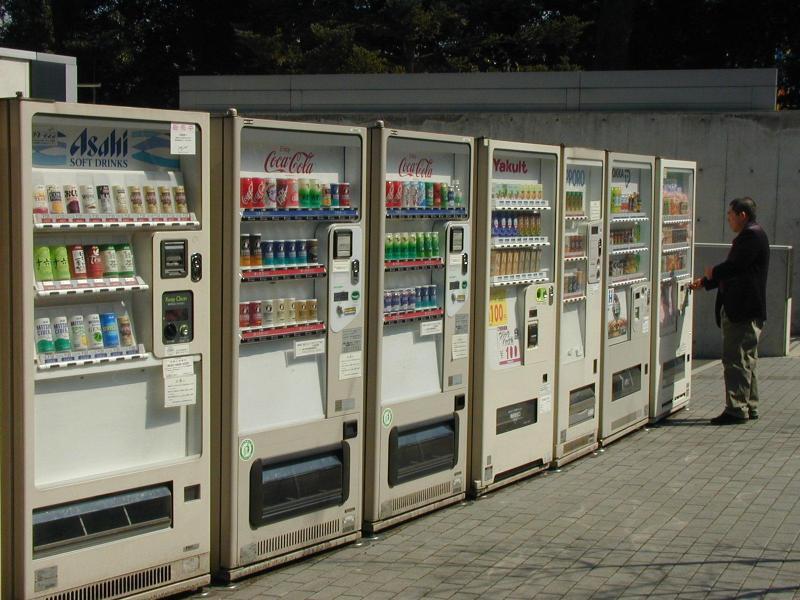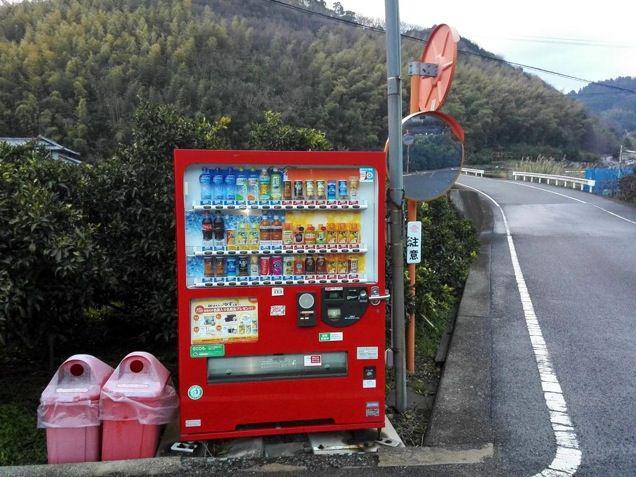The first image is the image on the left, the second image is the image on the right. Evaluate the accuracy of this statement regarding the images: "In one image, trash containers are sitting beside a vending machine.". Is it true? Answer yes or no. Yes. The first image is the image on the left, the second image is the image on the right. Given the left and right images, does the statement "One image contains exactly one red vending machine." hold true? Answer yes or no. Yes. 